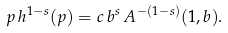Convert formula to latex. <formula><loc_0><loc_0><loc_500><loc_500>p \, h ^ { 1 - s } ( p ) = c \, { b } ^ { s } \, A ^ { - ( 1 - s ) } ( 1 , b ) .</formula> 